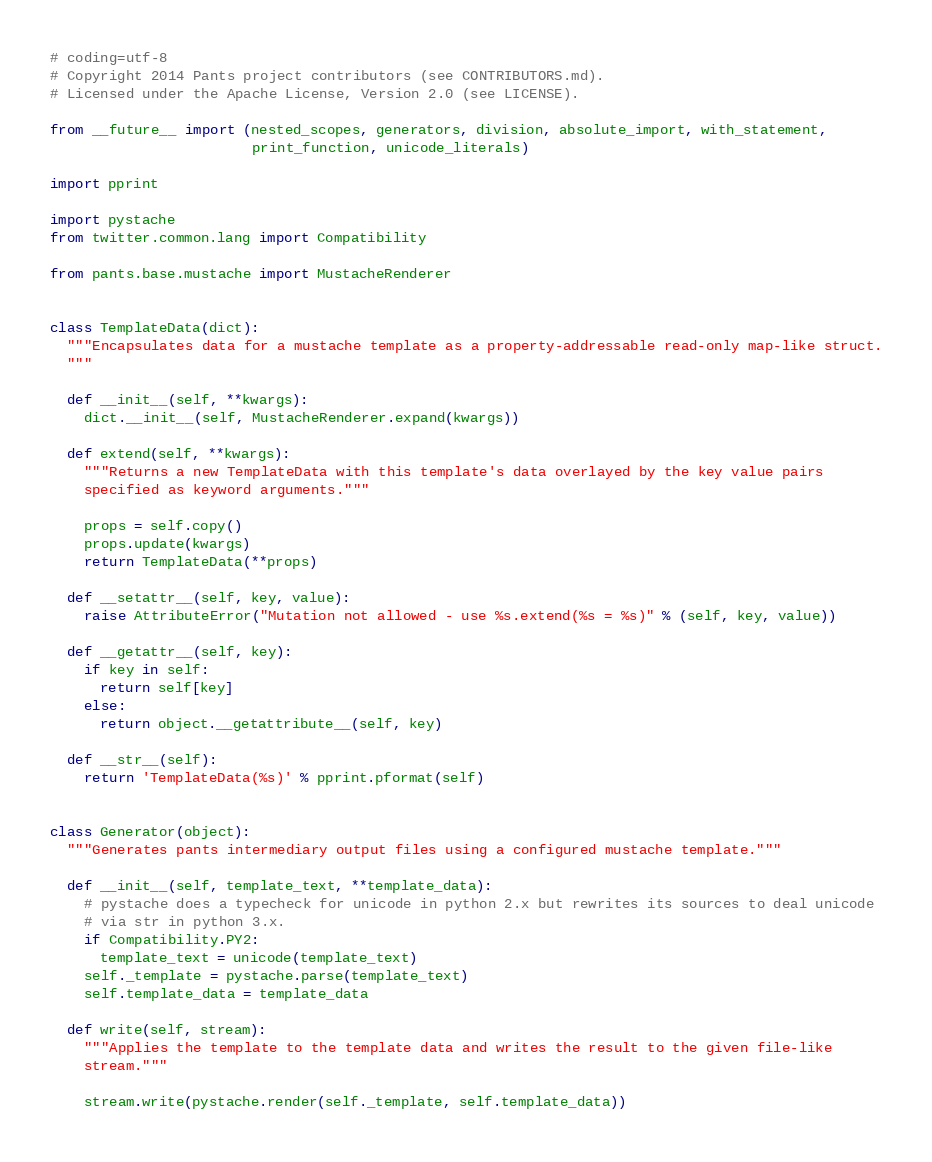<code> <loc_0><loc_0><loc_500><loc_500><_Python_># coding=utf-8
# Copyright 2014 Pants project contributors (see CONTRIBUTORS.md).
# Licensed under the Apache License, Version 2.0 (see LICENSE).

from __future__ import (nested_scopes, generators, division, absolute_import, with_statement,
                        print_function, unicode_literals)

import pprint

import pystache
from twitter.common.lang import Compatibility

from pants.base.mustache import MustacheRenderer


class TemplateData(dict):
  """Encapsulates data for a mustache template as a property-addressable read-only map-like struct.
  """

  def __init__(self, **kwargs):
    dict.__init__(self, MustacheRenderer.expand(kwargs))

  def extend(self, **kwargs):
    """Returns a new TemplateData with this template's data overlayed by the key value pairs
    specified as keyword arguments."""

    props = self.copy()
    props.update(kwargs)
    return TemplateData(**props)

  def __setattr__(self, key, value):
    raise AttributeError("Mutation not allowed - use %s.extend(%s = %s)" % (self, key, value))

  def __getattr__(self, key):
    if key in self:
      return self[key]
    else:
      return object.__getattribute__(self, key)

  def __str__(self):
    return 'TemplateData(%s)' % pprint.pformat(self)


class Generator(object):
  """Generates pants intermediary output files using a configured mustache template."""

  def __init__(self, template_text, **template_data):
    # pystache does a typecheck for unicode in python 2.x but rewrites its sources to deal unicode
    # via str in python 3.x.
    if Compatibility.PY2:
      template_text = unicode(template_text)
    self._template = pystache.parse(template_text)
    self.template_data = template_data

  def write(self, stream):
    """Applies the template to the template data and writes the result to the given file-like
    stream."""

    stream.write(pystache.render(self._template, self.template_data))
</code> 